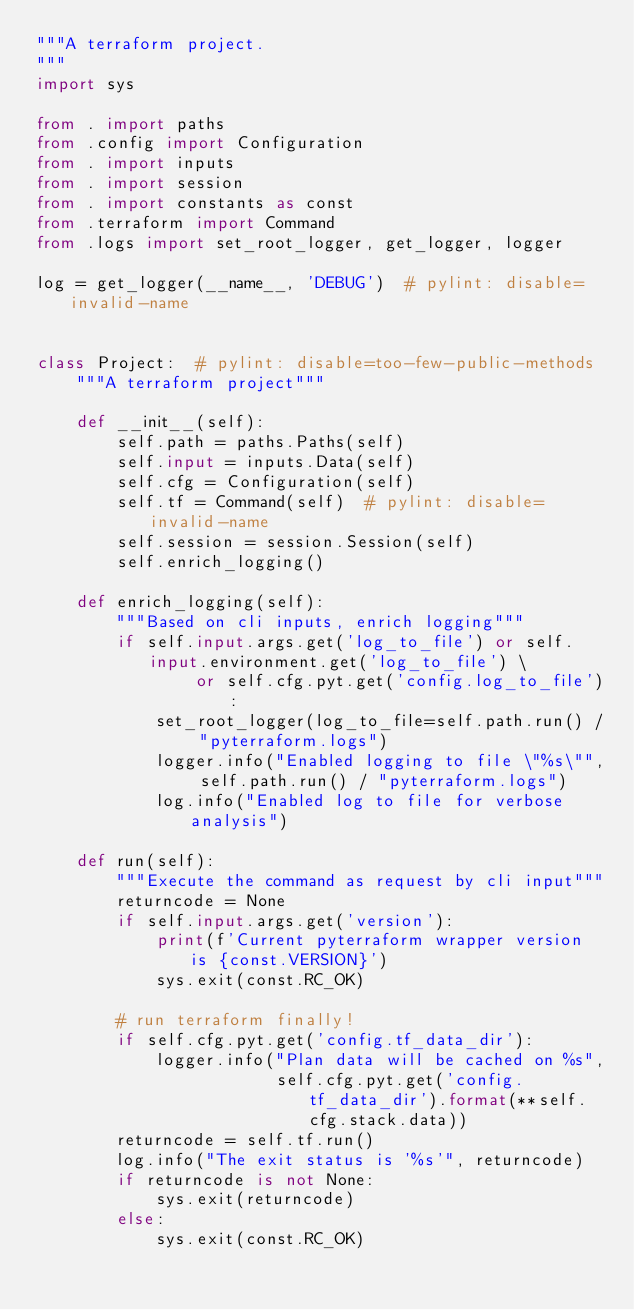Convert code to text. <code><loc_0><loc_0><loc_500><loc_500><_Python_>"""A terraform project.
"""
import sys

from . import paths
from .config import Configuration
from . import inputs
from . import session
from . import constants as const
from .terraform import Command
from .logs import set_root_logger, get_logger, logger

log = get_logger(__name__, 'DEBUG')  # pylint: disable=invalid-name


class Project:  # pylint: disable=too-few-public-methods
    """A terraform project"""

    def __init__(self):
        self.path = paths.Paths(self)
        self.input = inputs.Data(self)
        self.cfg = Configuration(self)
        self.tf = Command(self)  # pylint: disable=invalid-name
        self.session = session.Session(self)
        self.enrich_logging()

    def enrich_logging(self):
        """Based on cli inputs, enrich logging"""
        if self.input.args.get('log_to_file') or self.input.environment.get('log_to_file') \
                or self.cfg.pyt.get('config.log_to_file'):
            set_root_logger(log_to_file=self.path.run() / "pyterraform.logs")
            logger.info("Enabled logging to file \"%s\"", self.path.run() / "pyterraform.logs")
            log.info("Enabled log to file for verbose analysis")

    def run(self):
        """Execute the command as request by cli input"""
        returncode = None
        if self.input.args.get('version'):
            print(f'Current pyterraform wrapper version is {const.VERSION}')
            sys.exit(const.RC_OK)

        # run terraform finally!
        if self.cfg.pyt.get('config.tf_data_dir'):
            logger.info("Plan data will be cached on %s",
                        self.cfg.pyt.get('config.tf_data_dir').format(**self.cfg.stack.data))
        returncode = self.tf.run()
        log.info("The exit status is '%s'", returncode)
        if returncode is not None:
            sys.exit(returncode)
        else:
            sys.exit(const.RC_OK)
</code> 